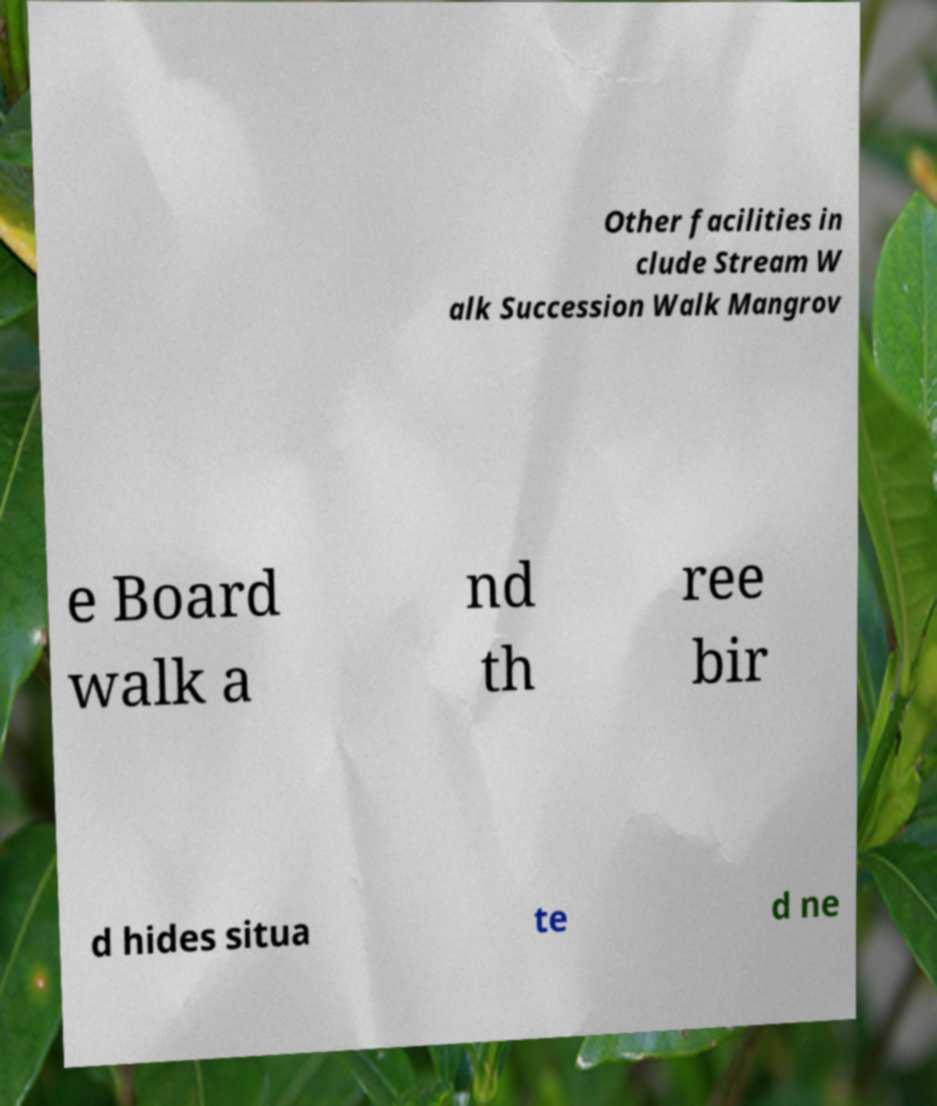Can you read and provide the text displayed in the image?This photo seems to have some interesting text. Can you extract and type it out for me? Other facilities in clude Stream W alk Succession Walk Mangrov e Board walk a nd th ree bir d hides situa te d ne 